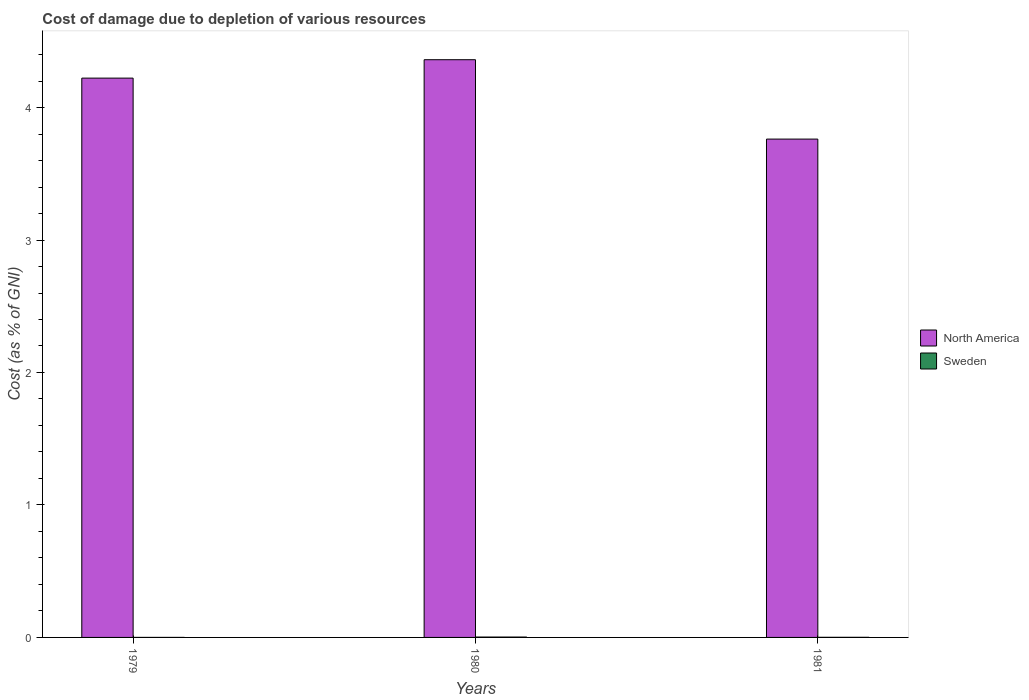How many groups of bars are there?
Offer a very short reply. 3. Are the number of bars on each tick of the X-axis equal?
Your response must be concise. Yes. In how many cases, is the number of bars for a given year not equal to the number of legend labels?
Your response must be concise. 0. What is the cost of damage caused due to the depletion of various resources in Sweden in 1979?
Make the answer very short. 0. Across all years, what is the maximum cost of damage caused due to the depletion of various resources in Sweden?
Give a very brief answer. 0. Across all years, what is the minimum cost of damage caused due to the depletion of various resources in Sweden?
Give a very brief answer. 0. In which year was the cost of damage caused due to the depletion of various resources in North America maximum?
Provide a short and direct response. 1980. In which year was the cost of damage caused due to the depletion of various resources in North America minimum?
Make the answer very short. 1981. What is the total cost of damage caused due to the depletion of various resources in North America in the graph?
Offer a terse response. 12.35. What is the difference between the cost of damage caused due to the depletion of various resources in Sweden in 1980 and that in 1981?
Your answer should be compact. 0. What is the difference between the cost of damage caused due to the depletion of various resources in Sweden in 1981 and the cost of damage caused due to the depletion of various resources in North America in 1979?
Offer a very short reply. -4.22. What is the average cost of damage caused due to the depletion of various resources in Sweden per year?
Provide a succinct answer. 0. In the year 1979, what is the difference between the cost of damage caused due to the depletion of various resources in North America and cost of damage caused due to the depletion of various resources in Sweden?
Make the answer very short. 4.22. In how many years, is the cost of damage caused due to the depletion of various resources in North America greater than 4 %?
Your response must be concise. 2. What is the ratio of the cost of damage caused due to the depletion of various resources in Sweden in 1979 to that in 1981?
Your answer should be very brief. 0.15. What is the difference between the highest and the second highest cost of damage caused due to the depletion of various resources in North America?
Make the answer very short. 0.14. What is the difference between the highest and the lowest cost of damage caused due to the depletion of various resources in Sweden?
Your answer should be compact. 0. Is the sum of the cost of damage caused due to the depletion of various resources in North America in 1980 and 1981 greater than the maximum cost of damage caused due to the depletion of various resources in Sweden across all years?
Your answer should be compact. Yes. What is the difference between two consecutive major ticks on the Y-axis?
Offer a terse response. 1. Are the values on the major ticks of Y-axis written in scientific E-notation?
Your answer should be very brief. No. Does the graph contain any zero values?
Provide a short and direct response. No. Does the graph contain grids?
Your answer should be compact. No. How many legend labels are there?
Make the answer very short. 2. How are the legend labels stacked?
Your answer should be very brief. Vertical. What is the title of the graph?
Provide a short and direct response. Cost of damage due to depletion of various resources. Does "Cambodia" appear as one of the legend labels in the graph?
Give a very brief answer. No. What is the label or title of the Y-axis?
Ensure brevity in your answer.  Cost (as % of GNI). What is the Cost (as % of GNI) of North America in 1979?
Give a very brief answer. 4.22. What is the Cost (as % of GNI) in Sweden in 1979?
Give a very brief answer. 0. What is the Cost (as % of GNI) in North America in 1980?
Offer a terse response. 4.36. What is the Cost (as % of GNI) in Sweden in 1980?
Give a very brief answer. 0. What is the Cost (as % of GNI) in North America in 1981?
Offer a terse response. 3.76. What is the Cost (as % of GNI) in Sweden in 1981?
Provide a succinct answer. 0. Across all years, what is the maximum Cost (as % of GNI) in North America?
Your response must be concise. 4.36. Across all years, what is the maximum Cost (as % of GNI) in Sweden?
Give a very brief answer. 0. Across all years, what is the minimum Cost (as % of GNI) of North America?
Your answer should be compact. 3.76. Across all years, what is the minimum Cost (as % of GNI) of Sweden?
Your response must be concise. 0. What is the total Cost (as % of GNI) of North America in the graph?
Ensure brevity in your answer.  12.35. What is the total Cost (as % of GNI) of Sweden in the graph?
Keep it short and to the point. 0. What is the difference between the Cost (as % of GNI) in North America in 1979 and that in 1980?
Ensure brevity in your answer.  -0.14. What is the difference between the Cost (as % of GNI) of Sweden in 1979 and that in 1980?
Your answer should be compact. -0. What is the difference between the Cost (as % of GNI) of North America in 1979 and that in 1981?
Offer a terse response. 0.46. What is the difference between the Cost (as % of GNI) of Sweden in 1979 and that in 1981?
Ensure brevity in your answer.  -0. What is the difference between the Cost (as % of GNI) of North America in 1980 and that in 1981?
Offer a very short reply. 0.6. What is the difference between the Cost (as % of GNI) of Sweden in 1980 and that in 1981?
Your answer should be very brief. 0. What is the difference between the Cost (as % of GNI) in North America in 1979 and the Cost (as % of GNI) in Sweden in 1980?
Offer a terse response. 4.22. What is the difference between the Cost (as % of GNI) in North America in 1979 and the Cost (as % of GNI) in Sweden in 1981?
Give a very brief answer. 4.22. What is the difference between the Cost (as % of GNI) of North America in 1980 and the Cost (as % of GNI) of Sweden in 1981?
Keep it short and to the point. 4.36. What is the average Cost (as % of GNI) in North America per year?
Your answer should be very brief. 4.12. What is the average Cost (as % of GNI) of Sweden per year?
Your answer should be very brief. 0. In the year 1979, what is the difference between the Cost (as % of GNI) in North America and Cost (as % of GNI) in Sweden?
Your answer should be compact. 4.22. In the year 1980, what is the difference between the Cost (as % of GNI) of North America and Cost (as % of GNI) of Sweden?
Offer a very short reply. 4.36. In the year 1981, what is the difference between the Cost (as % of GNI) of North America and Cost (as % of GNI) of Sweden?
Your answer should be compact. 3.76. What is the ratio of the Cost (as % of GNI) of North America in 1979 to that in 1980?
Offer a terse response. 0.97. What is the ratio of the Cost (as % of GNI) of Sweden in 1979 to that in 1980?
Give a very brief answer. 0.04. What is the ratio of the Cost (as % of GNI) of North America in 1979 to that in 1981?
Provide a succinct answer. 1.12. What is the ratio of the Cost (as % of GNI) in Sweden in 1979 to that in 1981?
Make the answer very short. 0.15. What is the ratio of the Cost (as % of GNI) in North America in 1980 to that in 1981?
Your answer should be compact. 1.16. What is the ratio of the Cost (as % of GNI) of Sweden in 1980 to that in 1981?
Your response must be concise. 3.46. What is the difference between the highest and the second highest Cost (as % of GNI) in North America?
Offer a terse response. 0.14. What is the difference between the highest and the second highest Cost (as % of GNI) of Sweden?
Provide a succinct answer. 0. What is the difference between the highest and the lowest Cost (as % of GNI) in North America?
Provide a short and direct response. 0.6. What is the difference between the highest and the lowest Cost (as % of GNI) of Sweden?
Your response must be concise. 0. 